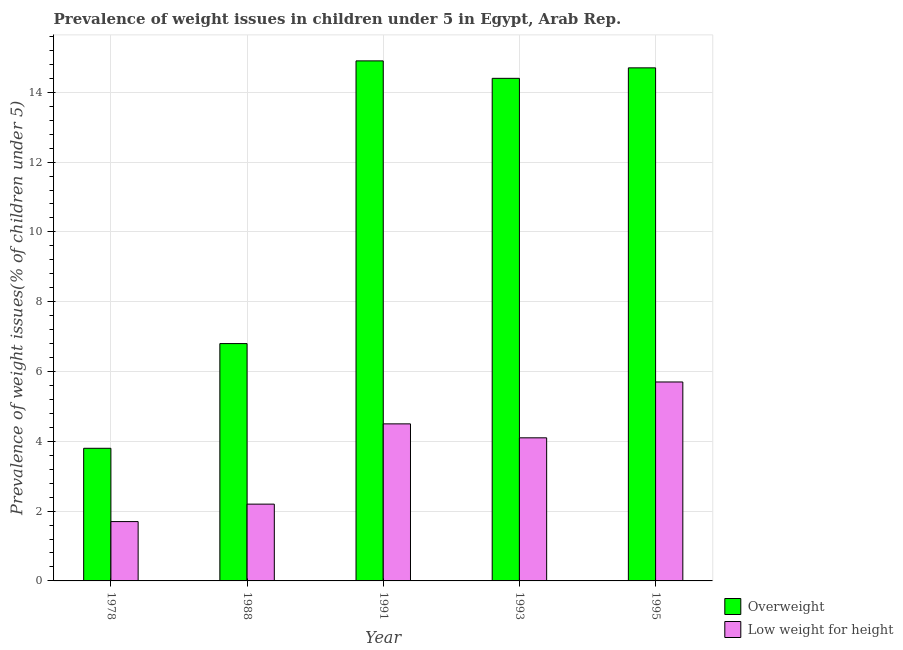Are the number of bars per tick equal to the number of legend labels?
Offer a very short reply. Yes. Are the number of bars on each tick of the X-axis equal?
Offer a very short reply. Yes. What is the label of the 2nd group of bars from the left?
Your answer should be very brief. 1988. What is the percentage of overweight children in 1993?
Your answer should be very brief. 14.4. Across all years, what is the maximum percentage of underweight children?
Offer a terse response. 5.7. Across all years, what is the minimum percentage of underweight children?
Offer a very short reply. 1.7. In which year was the percentage of underweight children maximum?
Ensure brevity in your answer.  1995. In which year was the percentage of underweight children minimum?
Provide a short and direct response. 1978. What is the total percentage of underweight children in the graph?
Give a very brief answer. 18.2. What is the difference between the percentage of overweight children in 1995 and the percentage of underweight children in 1988?
Keep it short and to the point. 7.9. What is the average percentage of underweight children per year?
Keep it short and to the point. 3.64. In the year 1995, what is the difference between the percentage of overweight children and percentage of underweight children?
Provide a succinct answer. 0. In how many years, is the percentage of overweight children greater than 4.4 %?
Ensure brevity in your answer.  4. What is the ratio of the percentage of overweight children in 1988 to that in 1991?
Your response must be concise. 0.46. Is the percentage of overweight children in 1978 less than that in 1993?
Make the answer very short. Yes. Is the difference between the percentage of underweight children in 1991 and 1995 greater than the difference between the percentage of overweight children in 1991 and 1995?
Give a very brief answer. No. What is the difference between the highest and the second highest percentage of overweight children?
Provide a short and direct response. 0.2. What is the difference between the highest and the lowest percentage of underweight children?
Keep it short and to the point. 4. Is the sum of the percentage of underweight children in 1978 and 1995 greater than the maximum percentage of overweight children across all years?
Your response must be concise. Yes. What does the 2nd bar from the left in 1978 represents?
Your response must be concise. Low weight for height. What does the 1st bar from the right in 1993 represents?
Keep it short and to the point. Low weight for height. How many bars are there?
Provide a short and direct response. 10. Are all the bars in the graph horizontal?
Offer a terse response. No. What is the difference between two consecutive major ticks on the Y-axis?
Your answer should be very brief. 2. Does the graph contain grids?
Offer a terse response. Yes. What is the title of the graph?
Give a very brief answer. Prevalence of weight issues in children under 5 in Egypt, Arab Rep. What is the label or title of the Y-axis?
Give a very brief answer. Prevalence of weight issues(% of children under 5). What is the Prevalence of weight issues(% of children under 5) in Overweight in 1978?
Make the answer very short. 3.8. What is the Prevalence of weight issues(% of children under 5) in Low weight for height in 1978?
Your answer should be compact. 1.7. What is the Prevalence of weight issues(% of children under 5) of Overweight in 1988?
Provide a short and direct response. 6.8. What is the Prevalence of weight issues(% of children under 5) of Low weight for height in 1988?
Your answer should be compact. 2.2. What is the Prevalence of weight issues(% of children under 5) in Overweight in 1991?
Offer a terse response. 14.9. What is the Prevalence of weight issues(% of children under 5) of Overweight in 1993?
Give a very brief answer. 14.4. What is the Prevalence of weight issues(% of children under 5) of Low weight for height in 1993?
Give a very brief answer. 4.1. What is the Prevalence of weight issues(% of children under 5) of Overweight in 1995?
Give a very brief answer. 14.7. What is the Prevalence of weight issues(% of children under 5) of Low weight for height in 1995?
Keep it short and to the point. 5.7. Across all years, what is the maximum Prevalence of weight issues(% of children under 5) of Overweight?
Your response must be concise. 14.9. Across all years, what is the maximum Prevalence of weight issues(% of children under 5) in Low weight for height?
Make the answer very short. 5.7. Across all years, what is the minimum Prevalence of weight issues(% of children under 5) of Overweight?
Keep it short and to the point. 3.8. Across all years, what is the minimum Prevalence of weight issues(% of children under 5) of Low weight for height?
Your answer should be very brief. 1.7. What is the total Prevalence of weight issues(% of children under 5) in Overweight in the graph?
Provide a succinct answer. 54.6. What is the total Prevalence of weight issues(% of children under 5) in Low weight for height in the graph?
Offer a terse response. 18.2. What is the difference between the Prevalence of weight issues(% of children under 5) in Low weight for height in 1978 and that in 1988?
Provide a short and direct response. -0.5. What is the difference between the Prevalence of weight issues(% of children under 5) in Low weight for height in 1978 and that in 1991?
Keep it short and to the point. -2.8. What is the difference between the Prevalence of weight issues(% of children under 5) of Overweight in 1978 and that in 1993?
Make the answer very short. -10.6. What is the difference between the Prevalence of weight issues(% of children under 5) in Low weight for height in 1988 and that in 1991?
Your answer should be very brief. -2.3. What is the difference between the Prevalence of weight issues(% of children under 5) in Overweight in 1988 and that in 1995?
Your answer should be compact. -7.9. What is the difference between the Prevalence of weight issues(% of children under 5) of Low weight for height in 1991 and that in 1993?
Offer a terse response. 0.4. What is the difference between the Prevalence of weight issues(% of children under 5) of Overweight in 1991 and that in 1995?
Make the answer very short. 0.2. What is the difference between the Prevalence of weight issues(% of children under 5) of Low weight for height in 1991 and that in 1995?
Offer a very short reply. -1.2. What is the difference between the Prevalence of weight issues(% of children under 5) of Overweight in 1993 and that in 1995?
Provide a short and direct response. -0.3. What is the difference between the Prevalence of weight issues(% of children under 5) in Overweight in 1978 and the Prevalence of weight issues(% of children under 5) in Low weight for height in 1988?
Provide a short and direct response. 1.6. What is the difference between the Prevalence of weight issues(% of children under 5) in Overweight in 1988 and the Prevalence of weight issues(% of children under 5) in Low weight for height in 1991?
Provide a short and direct response. 2.3. What is the difference between the Prevalence of weight issues(% of children under 5) of Overweight in 1988 and the Prevalence of weight issues(% of children under 5) of Low weight for height in 1995?
Your response must be concise. 1.1. What is the difference between the Prevalence of weight issues(% of children under 5) in Overweight in 1991 and the Prevalence of weight issues(% of children under 5) in Low weight for height in 1993?
Your answer should be compact. 10.8. What is the average Prevalence of weight issues(% of children under 5) in Overweight per year?
Give a very brief answer. 10.92. What is the average Prevalence of weight issues(% of children under 5) of Low weight for height per year?
Your answer should be compact. 3.64. In the year 1978, what is the difference between the Prevalence of weight issues(% of children under 5) in Overweight and Prevalence of weight issues(% of children under 5) in Low weight for height?
Provide a succinct answer. 2.1. In the year 1991, what is the difference between the Prevalence of weight issues(% of children under 5) in Overweight and Prevalence of weight issues(% of children under 5) in Low weight for height?
Keep it short and to the point. 10.4. In the year 1993, what is the difference between the Prevalence of weight issues(% of children under 5) in Overweight and Prevalence of weight issues(% of children under 5) in Low weight for height?
Keep it short and to the point. 10.3. What is the ratio of the Prevalence of weight issues(% of children under 5) of Overweight in 1978 to that in 1988?
Ensure brevity in your answer.  0.56. What is the ratio of the Prevalence of weight issues(% of children under 5) of Low weight for height in 1978 to that in 1988?
Ensure brevity in your answer.  0.77. What is the ratio of the Prevalence of weight issues(% of children under 5) of Overweight in 1978 to that in 1991?
Your answer should be compact. 0.26. What is the ratio of the Prevalence of weight issues(% of children under 5) of Low weight for height in 1978 to that in 1991?
Provide a short and direct response. 0.38. What is the ratio of the Prevalence of weight issues(% of children under 5) in Overweight in 1978 to that in 1993?
Ensure brevity in your answer.  0.26. What is the ratio of the Prevalence of weight issues(% of children under 5) of Low weight for height in 1978 to that in 1993?
Provide a succinct answer. 0.41. What is the ratio of the Prevalence of weight issues(% of children under 5) of Overweight in 1978 to that in 1995?
Keep it short and to the point. 0.26. What is the ratio of the Prevalence of weight issues(% of children under 5) of Low weight for height in 1978 to that in 1995?
Provide a succinct answer. 0.3. What is the ratio of the Prevalence of weight issues(% of children under 5) in Overweight in 1988 to that in 1991?
Offer a terse response. 0.46. What is the ratio of the Prevalence of weight issues(% of children under 5) of Low weight for height in 1988 to that in 1991?
Your answer should be very brief. 0.49. What is the ratio of the Prevalence of weight issues(% of children under 5) in Overweight in 1988 to that in 1993?
Make the answer very short. 0.47. What is the ratio of the Prevalence of weight issues(% of children under 5) in Low weight for height in 1988 to that in 1993?
Provide a succinct answer. 0.54. What is the ratio of the Prevalence of weight issues(% of children under 5) in Overweight in 1988 to that in 1995?
Make the answer very short. 0.46. What is the ratio of the Prevalence of weight issues(% of children under 5) of Low weight for height in 1988 to that in 1995?
Offer a terse response. 0.39. What is the ratio of the Prevalence of weight issues(% of children under 5) of Overweight in 1991 to that in 1993?
Offer a terse response. 1.03. What is the ratio of the Prevalence of weight issues(% of children under 5) in Low weight for height in 1991 to that in 1993?
Ensure brevity in your answer.  1.1. What is the ratio of the Prevalence of weight issues(% of children under 5) in Overweight in 1991 to that in 1995?
Make the answer very short. 1.01. What is the ratio of the Prevalence of weight issues(% of children under 5) of Low weight for height in 1991 to that in 1995?
Keep it short and to the point. 0.79. What is the ratio of the Prevalence of weight issues(% of children under 5) of Overweight in 1993 to that in 1995?
Keep it short and to the point. 0.98. What is the ratio of the Prevalence of weight issues(% of children under 5) of Low weight for height in 1993 to that in 1995?
Provide a short and direct response. 0.72. What is the difference between the highest and the second highest Prevalence of weight issues(% of children under 5) of Overweight?
Provide a succinct answer. 0.2. What is the difference between the highest and the second highest Prevalence of weight issues(% of children under 5) of Low weight for height?
Give a very brief answer. 1.2. 